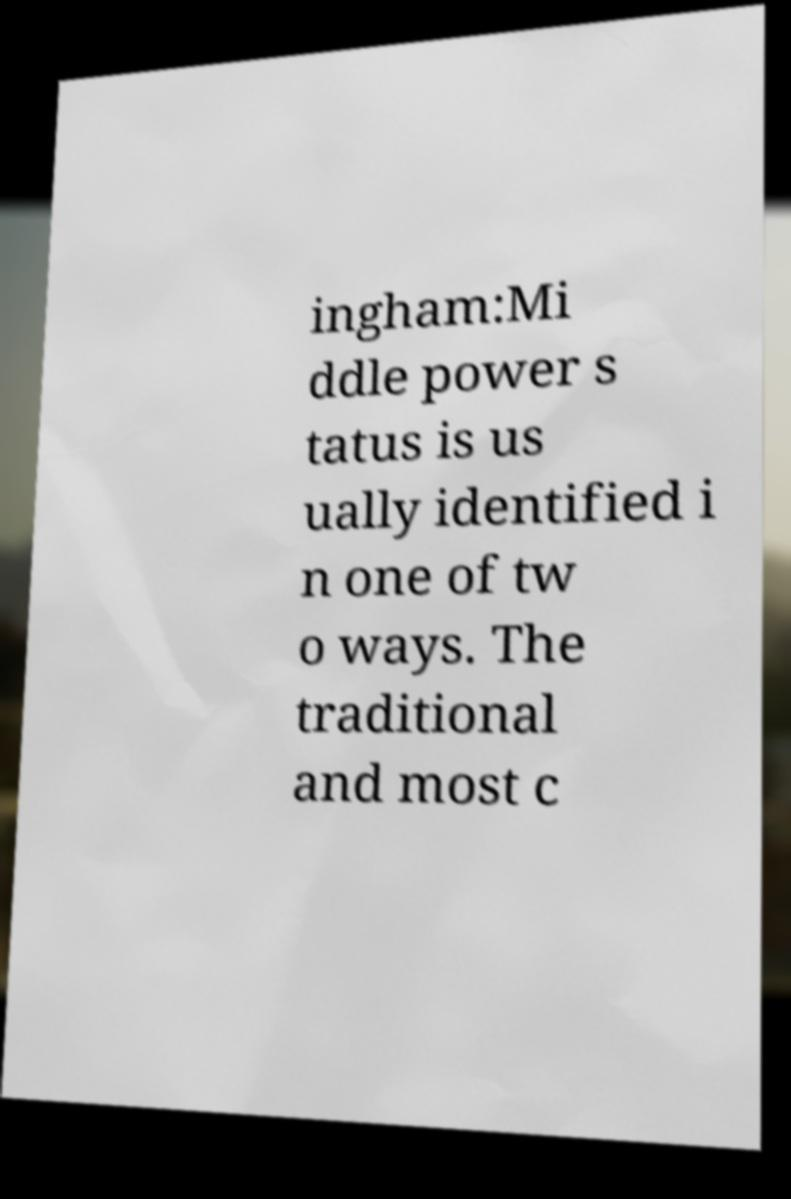Could you assist in decoding the text presented in this image and type it out clearly? ingham:Mi ddle power s tatus is us ually identified i n one of tw o ways. The traditional and most c 